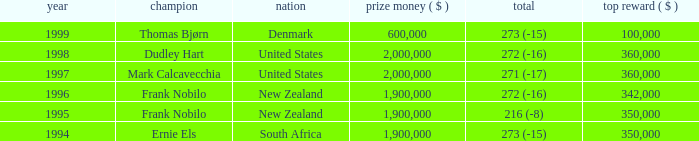What was the top first place prize in 1997? 360000.0. 